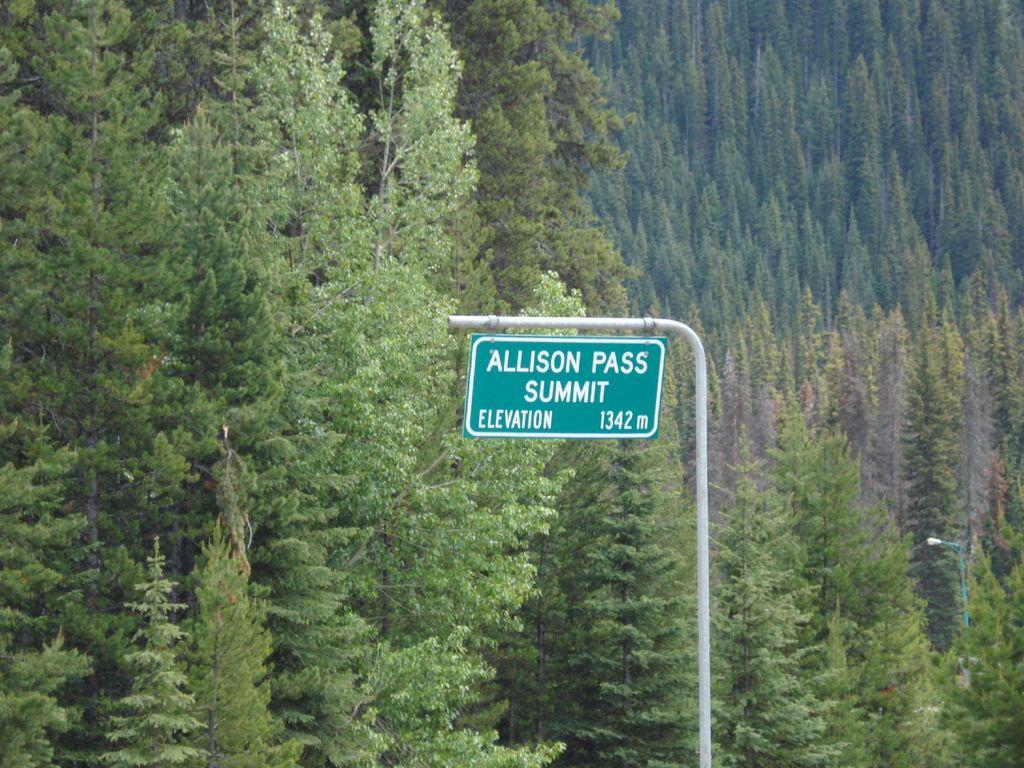What is the main object in the center of the image? There is a board in the center of the image. What can be seen in the background of the image? There are trees in the background of the image. What type of lighting is present on the right side of the image? There is a street light on the right side of the image. What color is the cushion on the board in the image? There is no cushion present on the board in the image. 